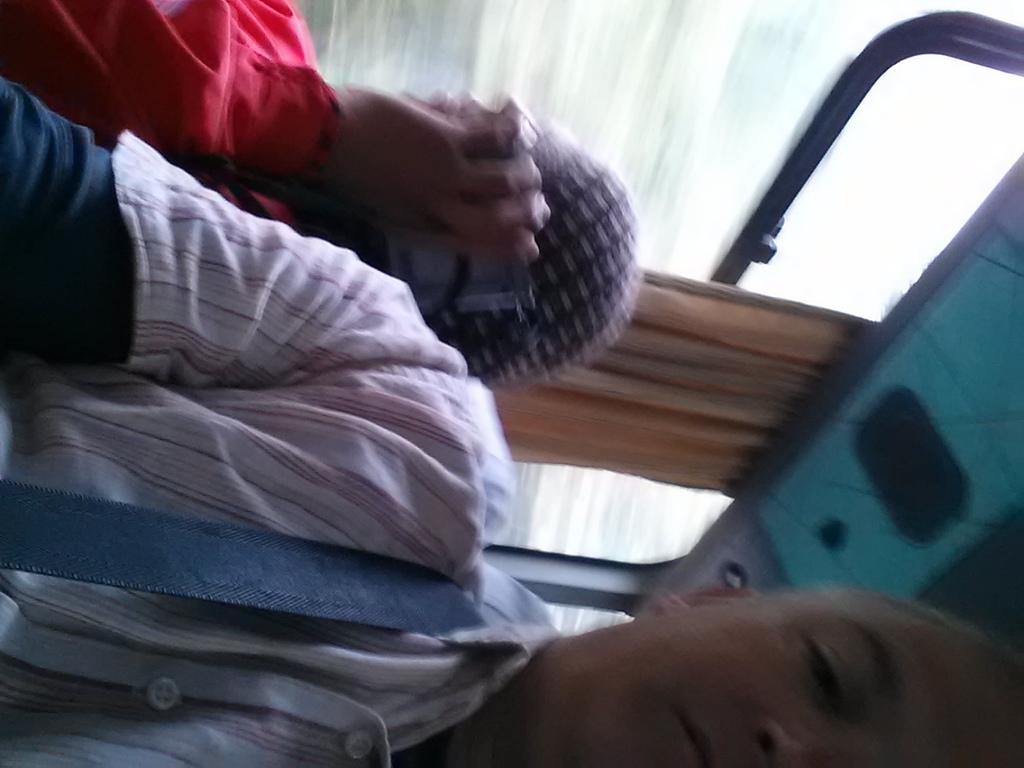How many people are in the image? There are two persons in the image. What are the persons doing in the image? The persons are sitting in a vehicle. What can be seen in the background of the image? There is a curtain visible in the image. Is there any opening in the vehicle? Yes, there is a window in the image. What type of fiction is the person reading in the image? There is no indication in the image that the person is reading any fiction. Can you tell me how the brain is functioning in the image? The image does not show any brain or provide information about brain function. 